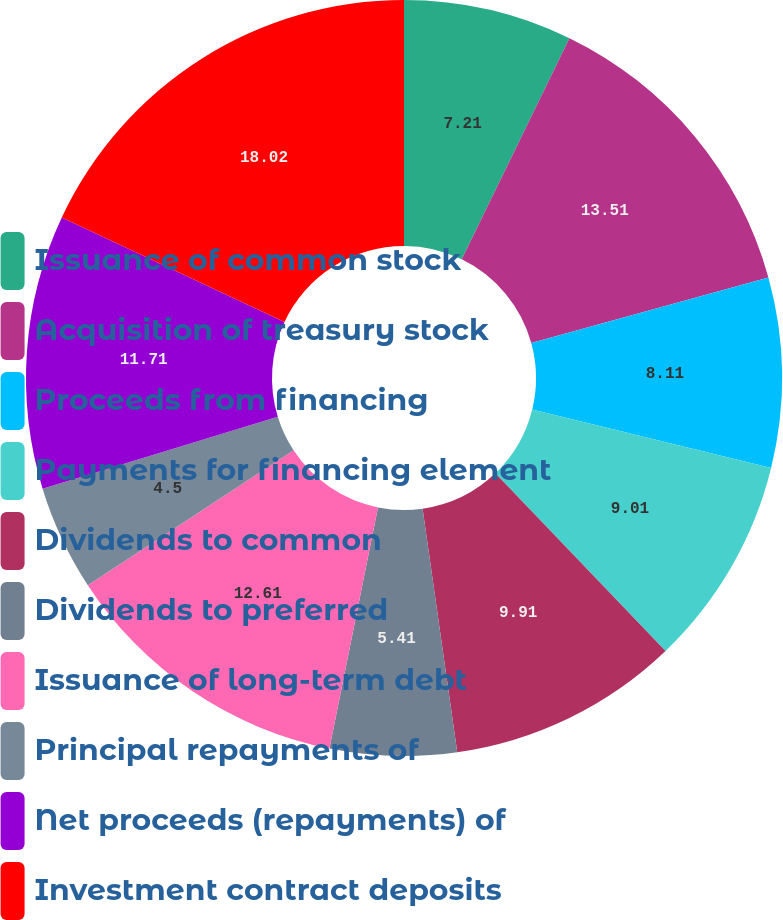<chart> <loc_0><loc_0><loc_500><loc_500><pie_chart><fcel>Issuance of common stock<fcel>Acquisition of treasury stock<fcel>Proceeds from financing<fcel>Payments for financing element<fcel>Dividends to common<fcel>Dividends to preferred<fcel>Issuance of long-term debt<fcel>Principal repayments of<fcel>Net proceeds (repayments) of<fcel>Investment contract deposits<nl><fcel>7.21%<fcel>13.51%<fcel>8.11%<fcel>9.01%<fcel>9.91%<fcel>5.41%<fcel>12.61%<fcel>4.5%<fcel>11.71%<fcel>18.02%<nl></chart> 